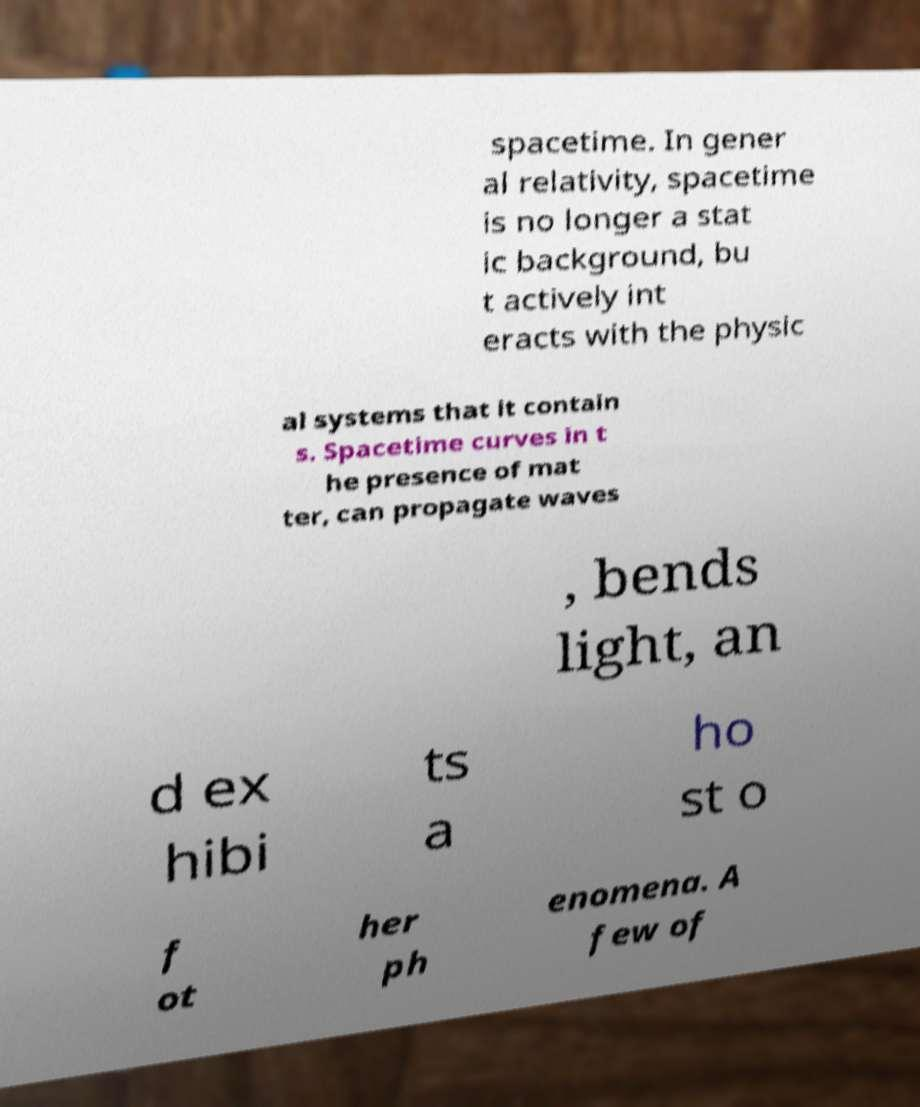Can you read and provide the text displayed in the image?This photo seems to have some interesting text. Can you extract and type it out for me? spacetime. In gener al relativity, spacetime is no longer a stat ic background, bu t actively int eracts with the physic al systems that it contain s. Spacetime curves in t he presence of mat ter, can propagate waves , bends light, an d ex hibi ts a ho st o f ot her ph enomena. A few of 